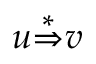<formula> <loc_0><loc_0><loc_500><loc_500>u { \stackrel { * } { \Rightarrow } } v</formula> 